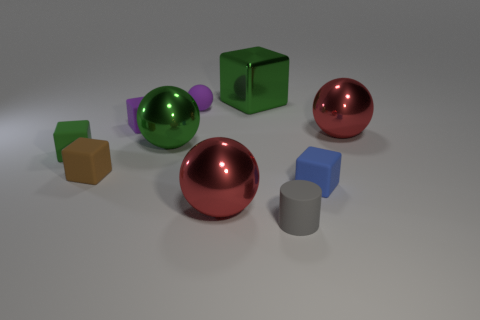Subtract all purple balls. How many balls are left? 3 Subtract all yellow balls. How many green cubes are left? 2 Subtract all blue cubes. How many cubes are left? 4 Subtract all cylinders. How many objects are left? 9 Subtract all gray cubes. Subtract all green balls. How many cubes are left? 5 Add 4 big spheres. How many big spheres are left? 7 Add 1 small gray rubber spheres. How many small gray rubber spheres exist? 1 Subtract 0 green cylinders. How many objects are left? 10 Subtract all small purple cubes. Subtract all brown rubber cubes. How many objects are left? 8 